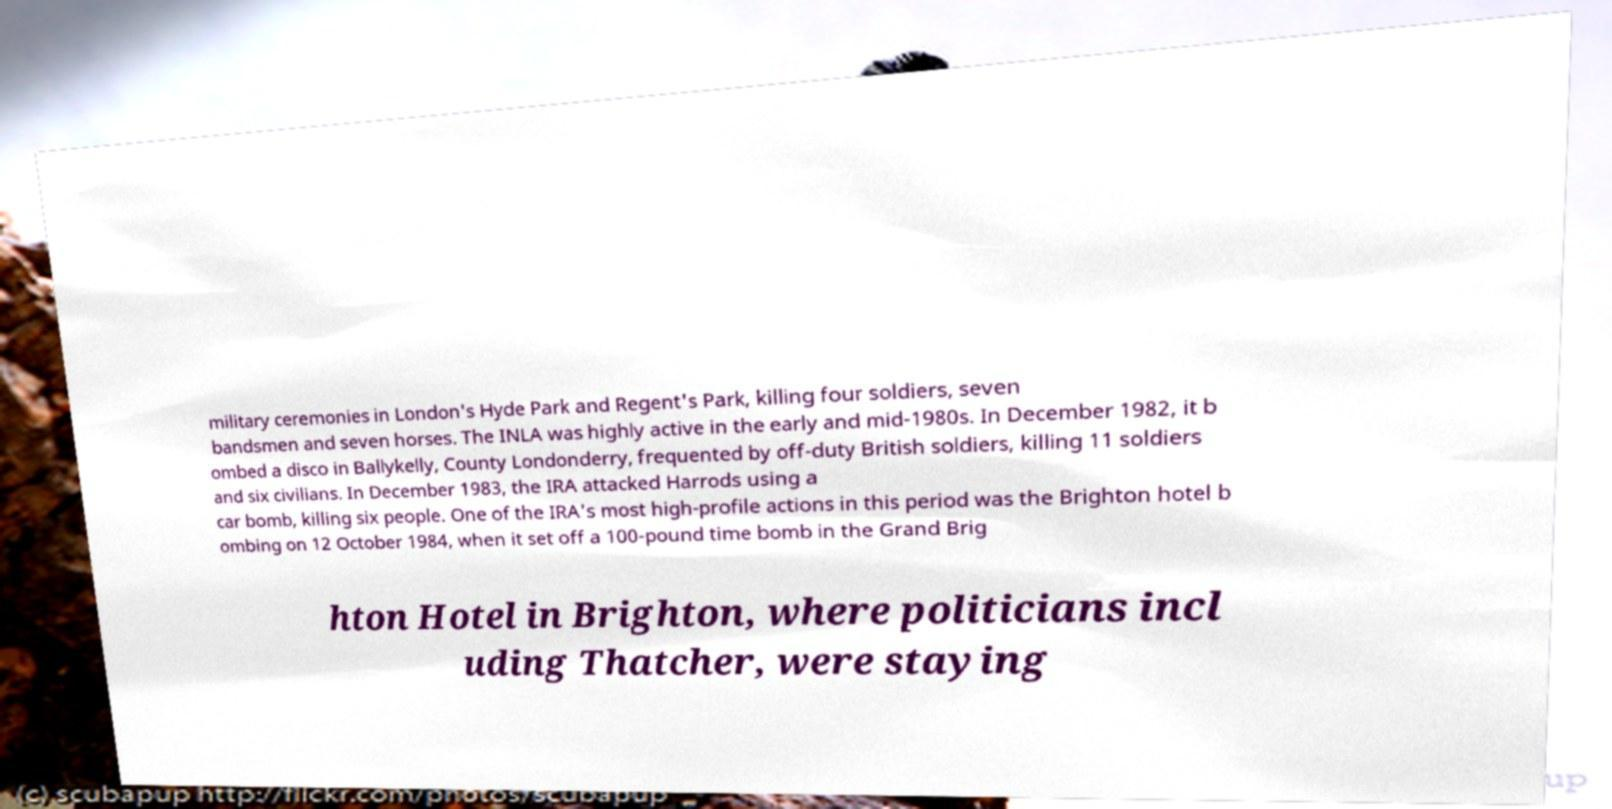Can you accurately transcribe the text from the provided image for me? military ceremonies in London's Hyde Park and Regent's Park, killing four soldiers, seven bandsmen and seven horses. The INLA was highly active in the early and mid-1980s. In December 1982, it b ombed a disco in Ballykelly, County Londonderry, frequented by off-duty British soldiers, killing 11 soldiers and six civilians. In December 1983, the IRA attacked Harrods using a car bomb, killing six people. One of the IRA's most high-profile actions in this period was the Brighton hotel b ombing on 12 October 1984, when it set off a 100-pound time bomb in the Grand Brig hton Hotel in Brighton, where politicians incl uding Thatcher, were staying 